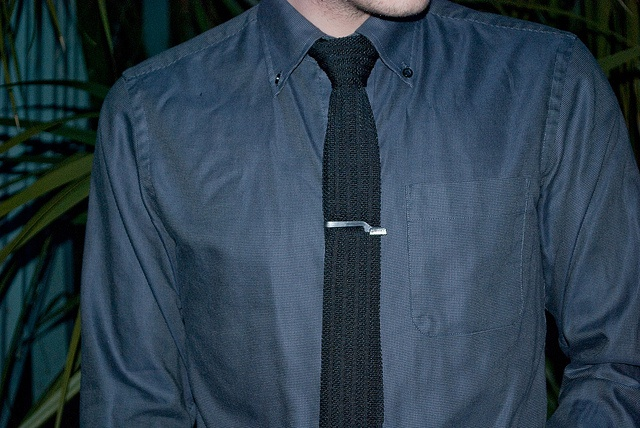Describe the objects in this image and their specific colors. I can see people in blue, black, and darkblue tones and tie in black, darkblue, and blue tones in this image. 